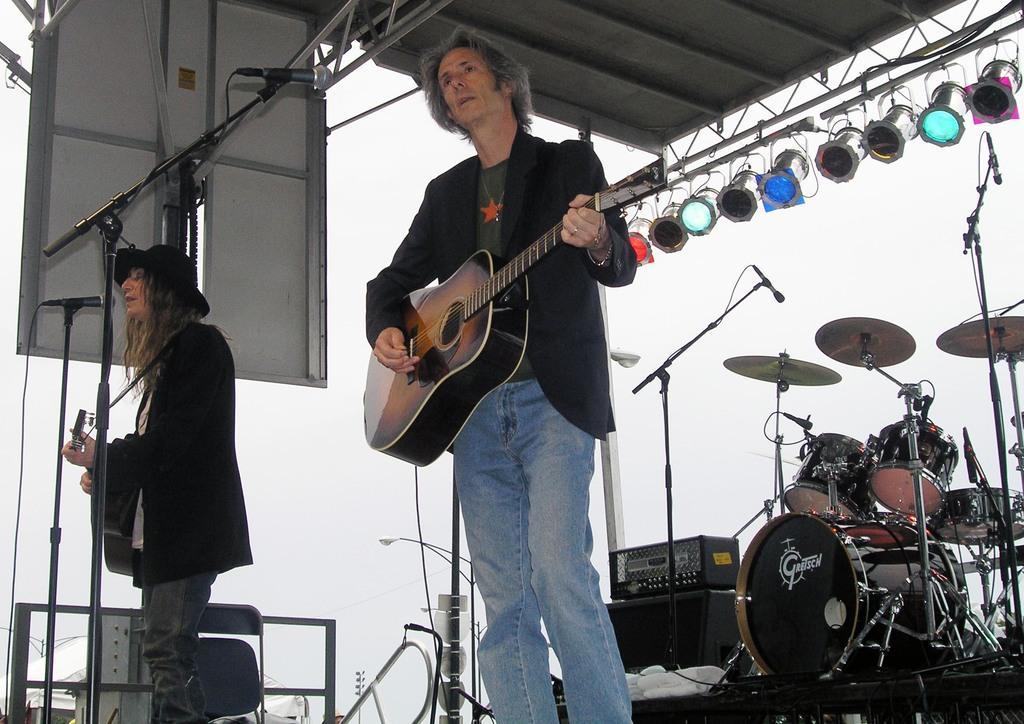How many people are in the image? There are two men in the image. What are the men holding in the image? Both men are holding guitars. What equipment is present in the image besides guitars? There is a microphone and a drum set in the image. What can be seen in the background of the image? Multiple lights are visible in the background. What type of dog can be seen playing with the guitar in the image? There is no dog present in the image, and no dog is playing with a guitar. 